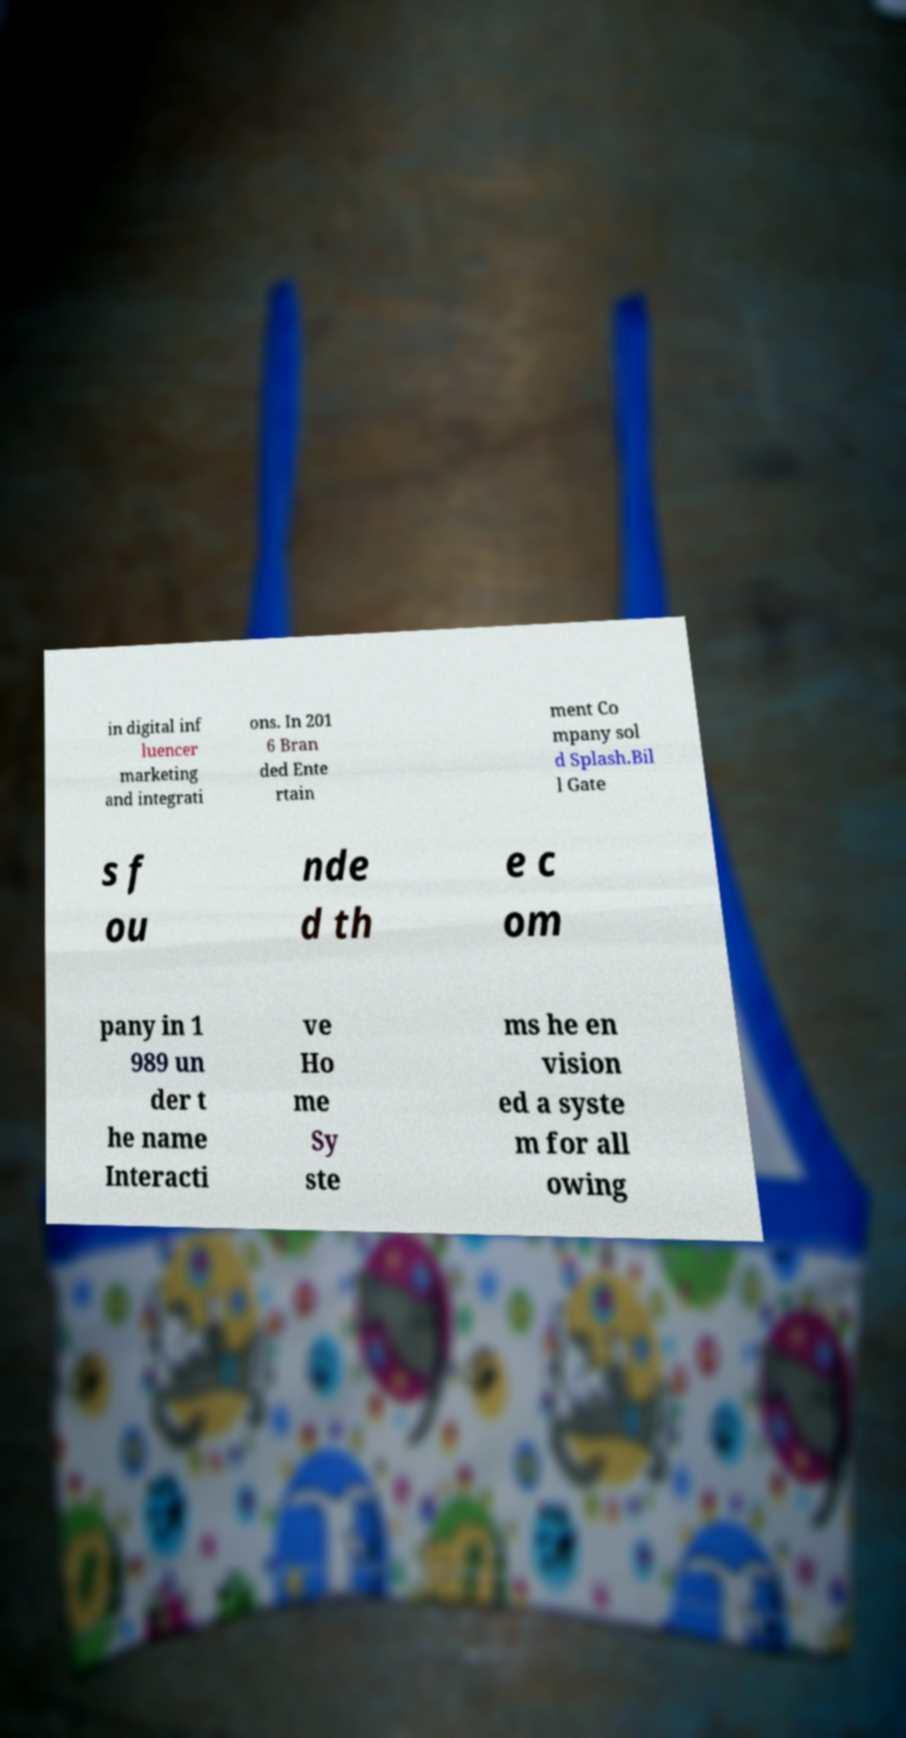Please identify and transcribe the text found in this image. in digital inf luencer marketing and integrati ons. In 201 6 Bran ded Ente rtain ment Co mpany sol d Splash.Bil l Gate s f ou nde d th e c om pany in 1 989 un der t he name Interacti ve Ho me Sy ste ms he en vision ed a syste m for all owing 